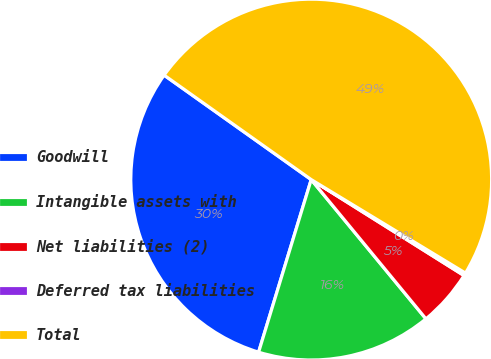Convert chart to OTSL. <chart><loc_0><loc_0><loc_500><loc_500><pie_chart><fcel>Goodwill<fcel>Intangible assets with<fcel>Net liabilities (2)<fcel>Deferred tax liabilities<fcel>Total<nl><fcel>30.12%<fcel>15.68%<fcel>5.11%<fcel>0.25%<fcel>48.85%<nl></chart> 